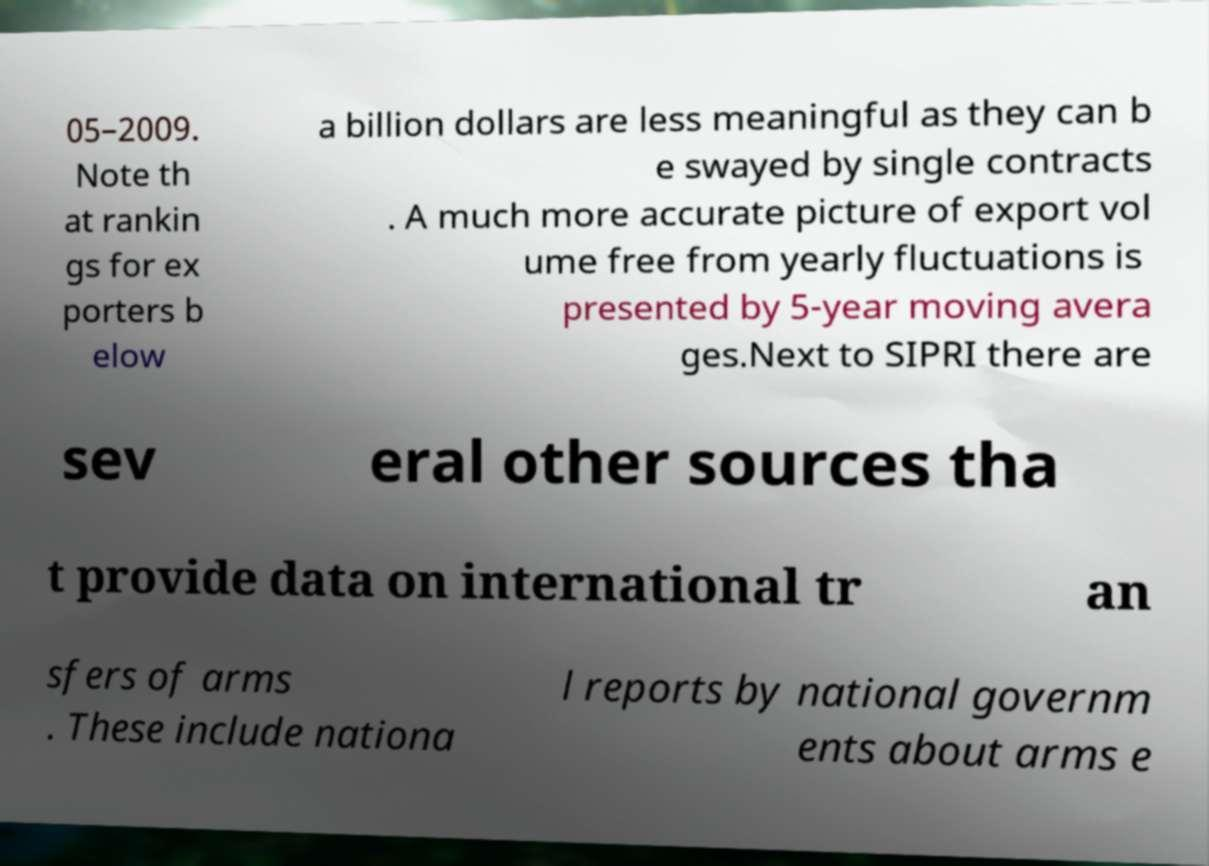Could you extract and type out the text from this image? 05–2009. Note th at rankin gs for ex porters b elow a billion dollars are less meaningful as they can b e swayed by single contracts . A much more accurate picture of export vol ume free from yearly fluctuations is presented by 5-year moving avera ges.Next to SIPRI there are sev eral other sources tha t provide data on international tr an sfers of arms . These include nationa l reports by national governm ents about arms e 